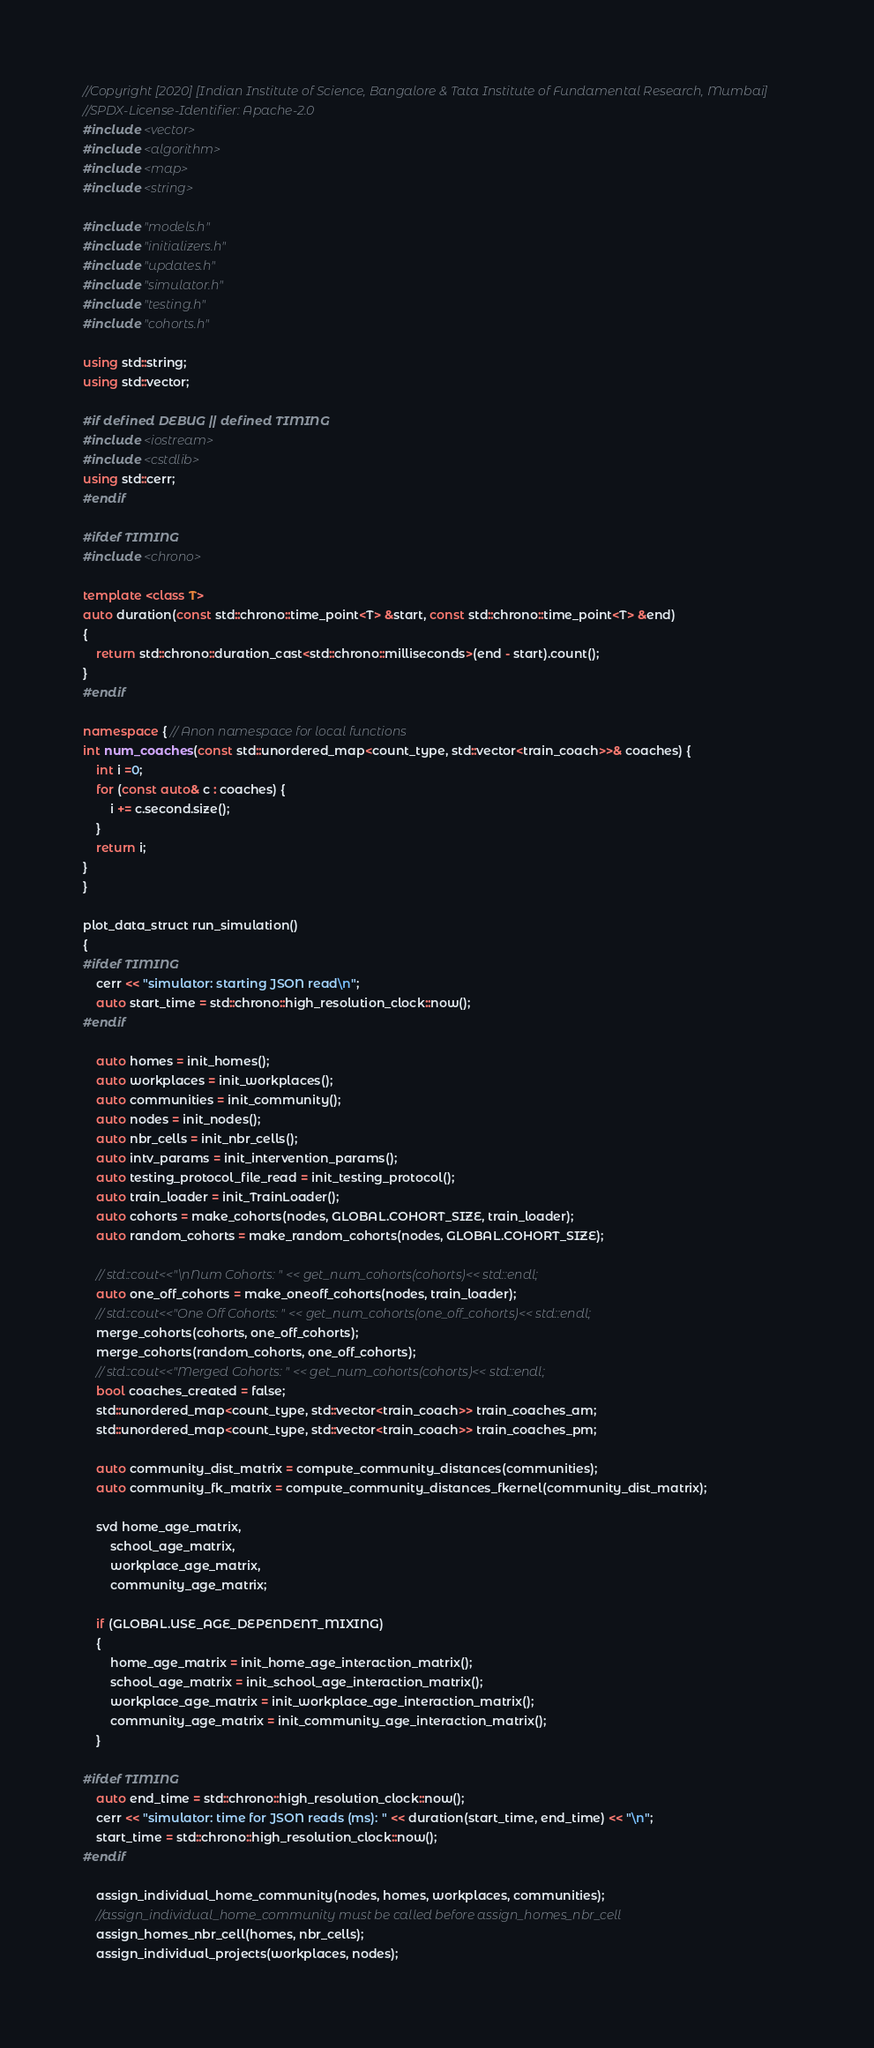<code> <loc_0><loc_0><loc_500><loc_500><_C++_>//Copyright [2020] [Indian Institute of Science, Bangalore & Tata Institute of Fundamental Research, Mumbai]
//SPDX-License-Identifier: Apache-2.0
#include <vector>
#include <algorithm>
#include <map>
#include <string>

#include "models.h"
#include "initializers.h"
#include "updates.h"
#include "simulator.h"
#include "testing.h"
#include "cohorts.h"

using std::string;
using std::vector;

#if defined DEBUG || defined TIMING
#include <iostream>
#include <cstdlib>
using std::cerr;
#endif

#ifdef TIMING
#include <chrono>

template <class T>
auto duration(const std::chrono::time_point<T> &start, const std::chrono::time_point<T> &end)
{
	return std::chrono::duration_cast<std::chrono::milliseconds>(end - start).count();
}
#endif

namespace { // Anon namespace for local functions
int num_coaches(const std::unordered_map<count_type, std::vector<train_coach>>& coaches) {
	int i =0;
	for (const auto& c : coaches) {
		i += c.second.size();
	}
	return i;
}
}

plot_data_struct run_simulation()
{
#ifdef TIMING
	cerr << "simulator: starting JSON read\n";
	auto start_time = std::chrono::high_resolution_clock::now();
#endif

	auto homes = init_homes();
	auto workplaces = init_workplaces();
	auto communities = init_community();
	auto nodes = init_nodes();
	auto nbr_cells = init_nbr_cells();
	auto intv_params = init_intervention_params();
	auto testing_protocol_file_read = init_testing_protocol();
	auto train_loader = init_TrainLoader();
	auto cohorts = make_cohorts(nodes, GLOBAL.COHORT_SIZE, train_loader);
	auto random_cohorts = make_random_cohorts(nodes, GLOBAL.COHORT_SIZE);

	// std::cout<<"\nNum Cohorts: " << get_num_cohorts(cohorts)<< std::endl;
	auto one_off_cohorts = make_oneoff_cohorts(nodes, train_loader);
	// std::cout<<"One Off Cohorts: " << get_num_cohorts(one_off_cohorts)<< std::endl;
	merge_cohorts(cohorts, one_off_cohorts);
	merge_cohorts(random_cohorts, one_off_cohorts);
	// std::cout<<"Merged Cohorts: " << get_num_cohorts(cohorts)<< std::endl;
	bool coaches_created = false;
	std::unordered_map<count_type, std::vector<train_coach>> train_coaches_am;
	std::unordered_map<count_type, std::vector<train_coach>> train_coaches_pm;

	auto community_dist_matrix = compute_community_distances(communities);
	auto community_fk_matrix = compute_community_distances_fkernel(community_dist_matrix);

	svd home_age_matrix,
		school_age_matrix,
		workplace_age_matrix,
		community_age_matrix;

	if (GLOBAL.USE_AGE_DEPENDENT_MIXING)
	{
		home_age_matrix = init_home_age_interaction_matrix();
		school_age_matrix = init_school_age_interaction_matrix();
		workplace_age_matrix = init_workplace_age_interaction_matrix();
		community_age_matrix = init_community_age_interaction_matrix();
	}

#ifdef TIMING
	auto end_time = std::chrono::high_resolution_clock::now();
	cerr << "simulator: time for JSON reads (ms): " << duration(start_time, end_time) << "\n";
	start_time = std::chrono::high_resolution_clock::now();
#endif

	assign_individual_home_community(nodes, homes, workplaces, communities);
	//assign_individual_home_community must be called before assign_homes_nbr_cell
	assign_homes_nbr_cell(homes, nbr_cells);
	assign_individual_projects(workplaces, nodes);</code> 